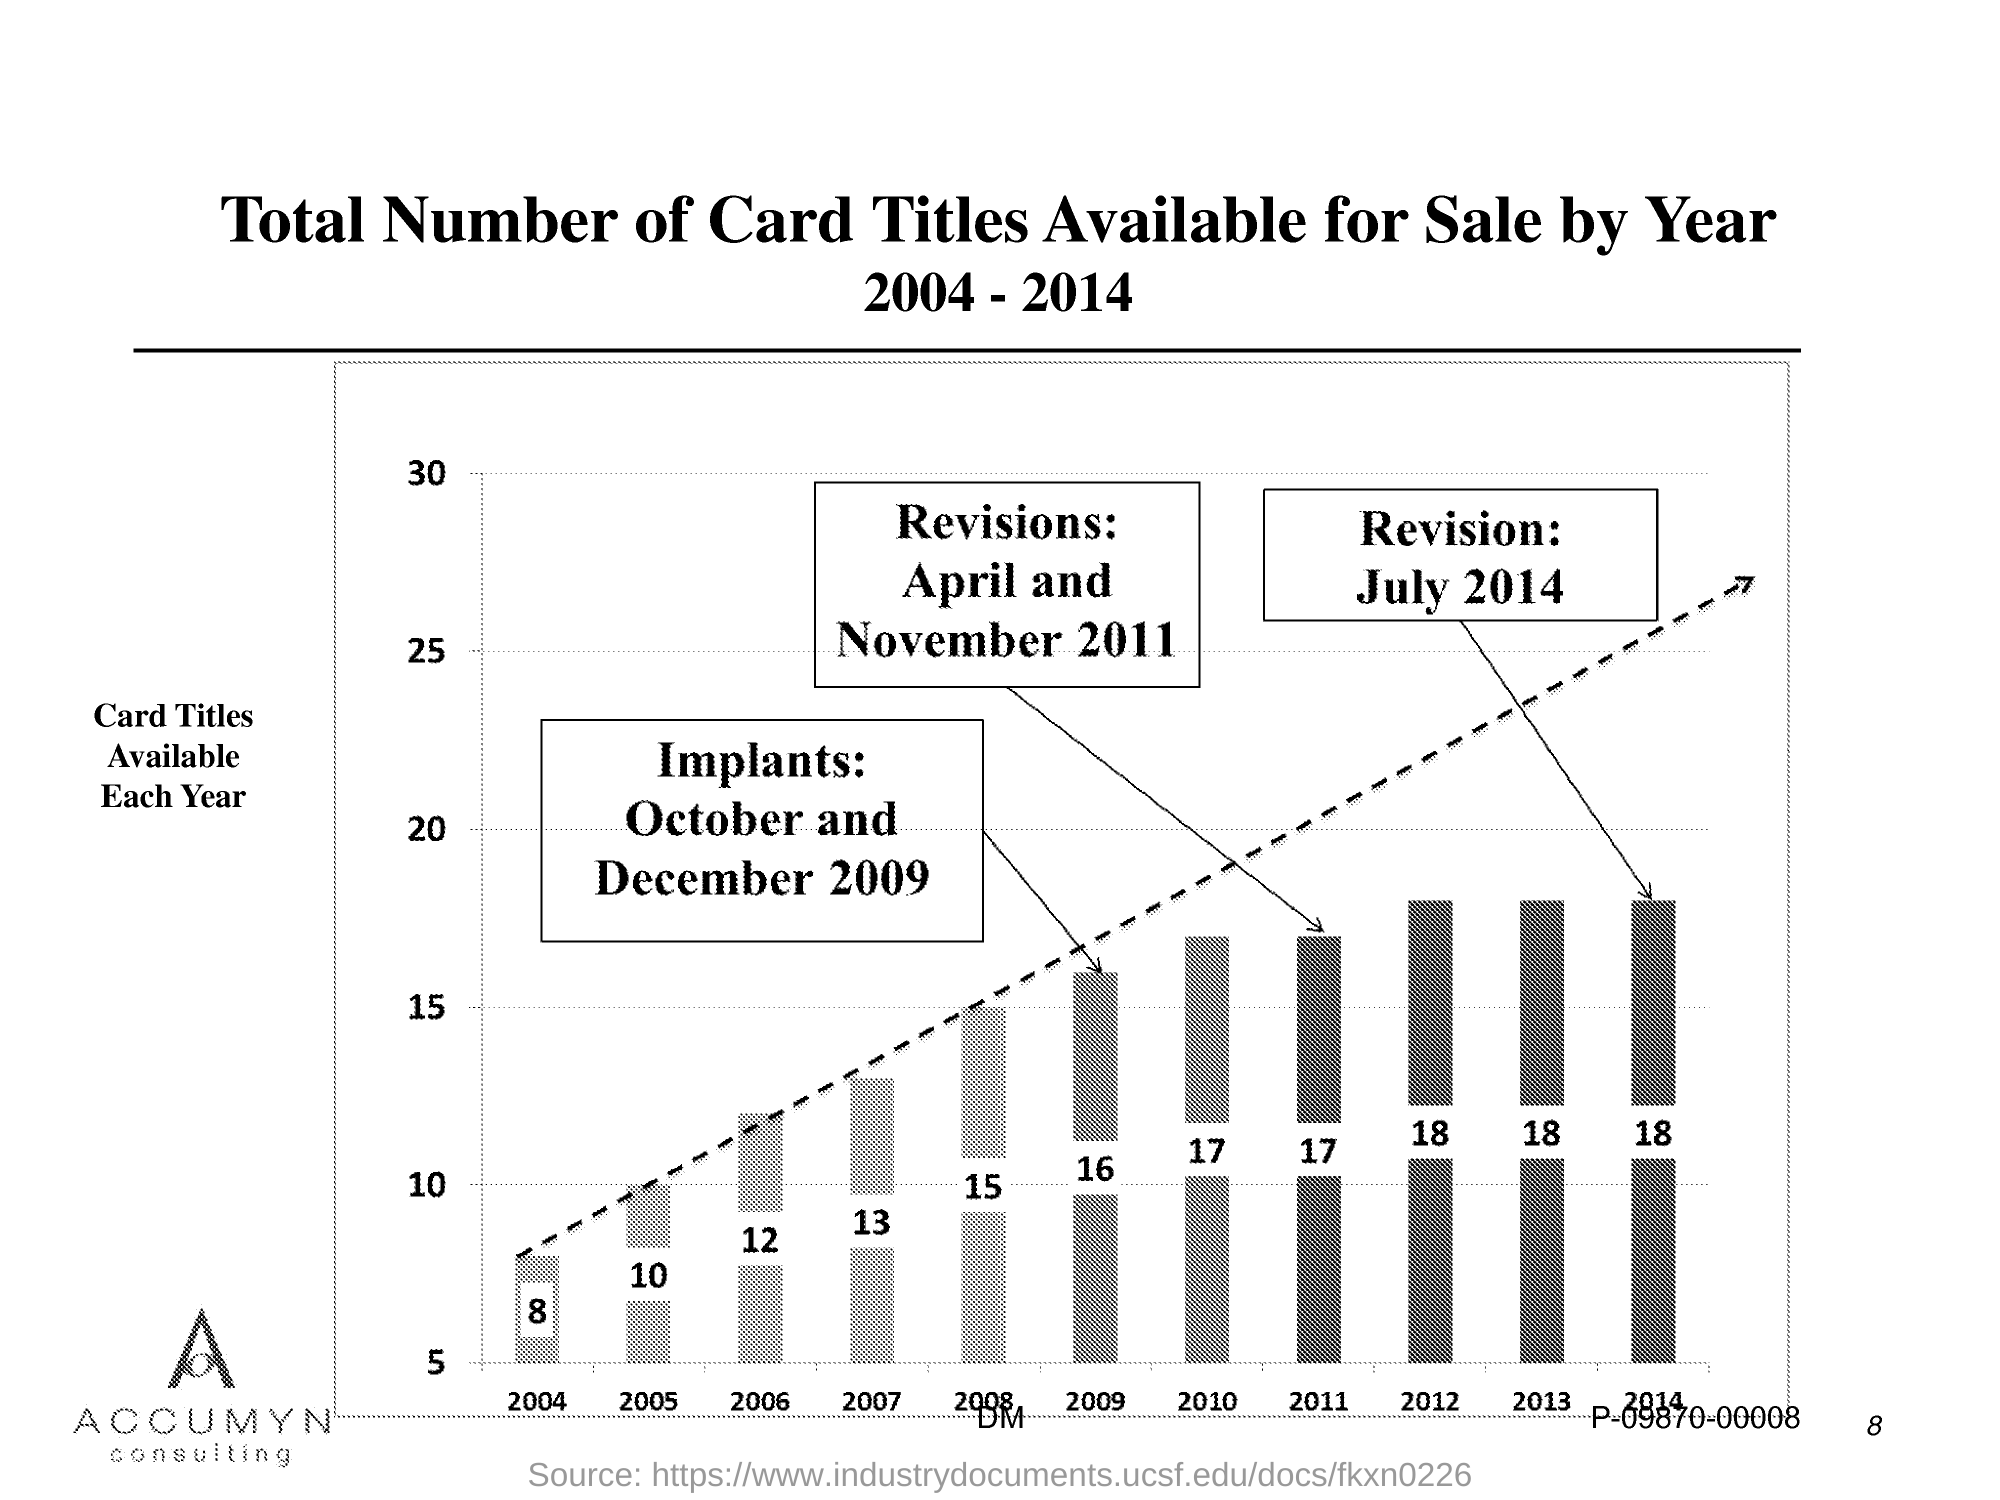Highlight a few significant elements in this photo. The number of available card titles per year is plotted on the y-axis. The page number is 8. 